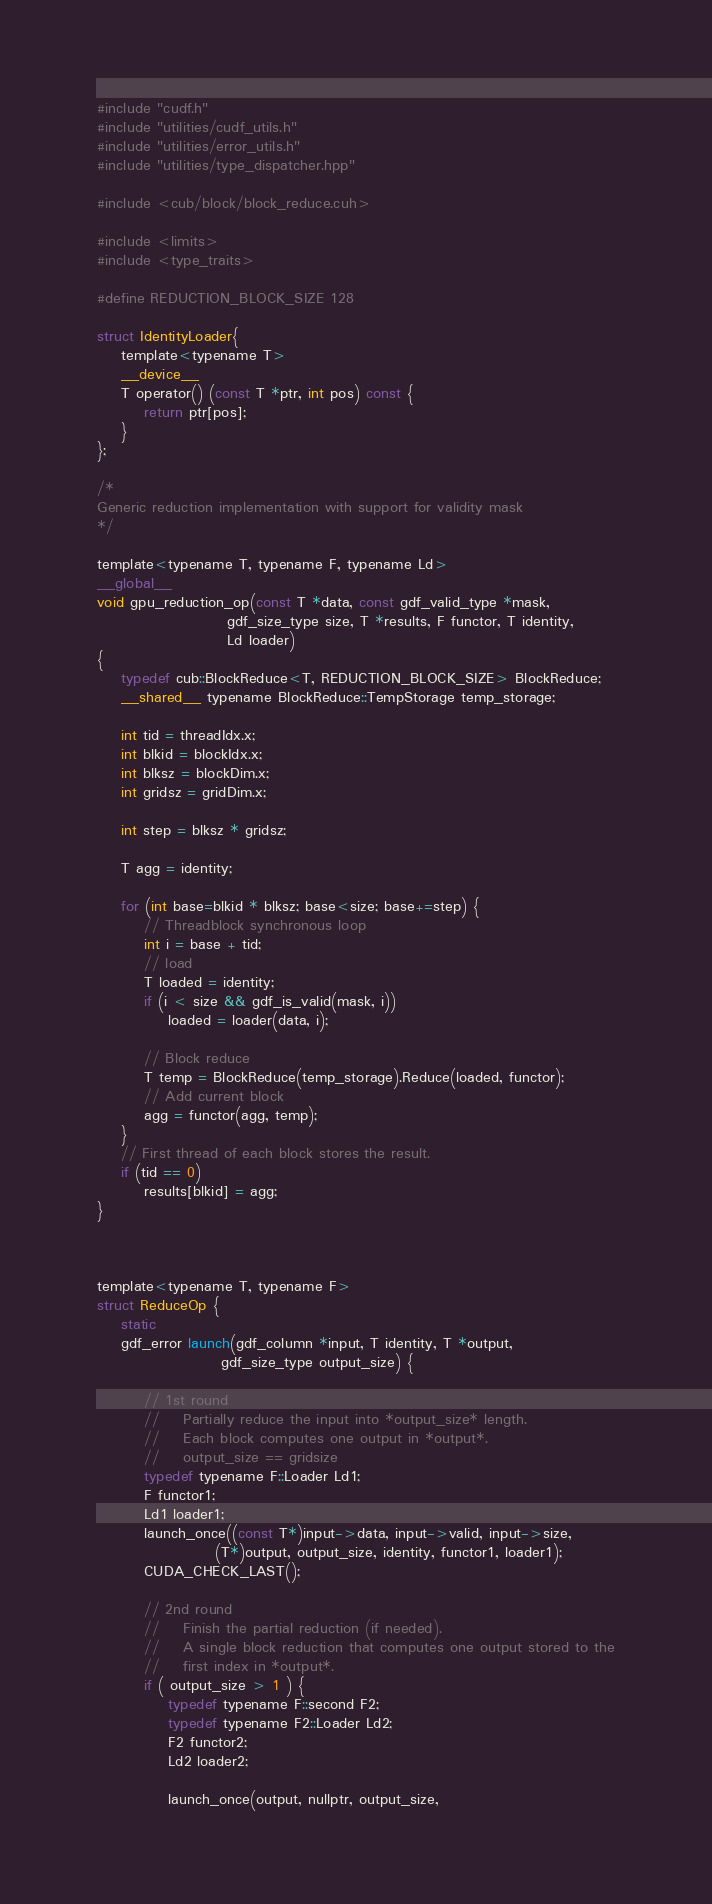<code> <loc_0><loc_0><loc_500><loc_500><_Cuda_>#include "cudf.h"
#include "utilities/cudf_utils.h"
#include "utilities/error_utils.h"
#include "utilities/type_dispatcher.hpp"

#include <cub/block/block_reduce.cuh>

#include <limits>
#include <type_traits>

#define REDUCTION_BLOCK_SIZE 128

struct IdentityLoader{
    template<typename T>
    __device__
    T operator() (const T *ptr, int pos) const {
        return ptr[pos];
    }
};

/*
Generic reduction implementation with support for validity mask
*/

template<typename T, typename F, typename Ld>
__global__
void gpu_reduction_op(const T *data, const gdf_valid_type *mask,
                      gdf_size_type size, T *results, F functor, T identity,
                      Ld loader)
{
    typedef cub::BlockReduce<T, REDUCTION_BLOCK_SIZE> BlockReduce;
    __shared__ typename BlockReduce::TempStorage temp_storage;

    int tid = threadIdx.x;
    int blkid = blockIdx.x;
    int blksz = blockDim.x;
    int gridsz = gridDim.x;

    int step = blksz * gridsz;

    T agg = identity;

    for (int base=blkid * blksz; base<size; base+=step) {
        // Threadblock synchronous loop
        int i = base + tid;
        // load
        T loaded = identity;
        if (i < size && gdf_is_valid(mask, i))
            loaded = loader(data, i);
            
        // Block reduce
        T temp = BlockReduce(temp_storage).Reduce(loaded, functor);
        // Add current block
        agg = functor(agg, temp);
    }
    // First thread of each block stores the result.
    if (tid == 0)
        results[blkid] = agg;
}



template<typename T, typename F>
struct ReduceOp {
    static
    gdf_error launch(gdf_column *input, T identity, T *output,
                     gdf_size_type output_size) {

        // 1st round
        //    Partially reduce the input into *output_size* length.
        //    Each block computes one output in *output*.
        //    output_size == gridsize
        typedef typename F::Loader Ld1;
        F functor1;
        Ld1 loader1;
        launch_once((const T*)input->data, input->valid, input->size,
                    (T*)output, output_size, identity, functor1, loader1);
        CUDA_CHECK_LAST();

        // 2nd round
        //    Finish the partial reduction (if needed).
        //    A single block reduction that computes one output stored to the
        //    first index in *output*.
        if ( output_size > 1 ) {
            typedef typename F::second F2;
            typedef typename F2::Loader Ld2;
            F2 functor2;
            Ld2 loader2;

            launch_once(output, nullptr, output_size,</code> 